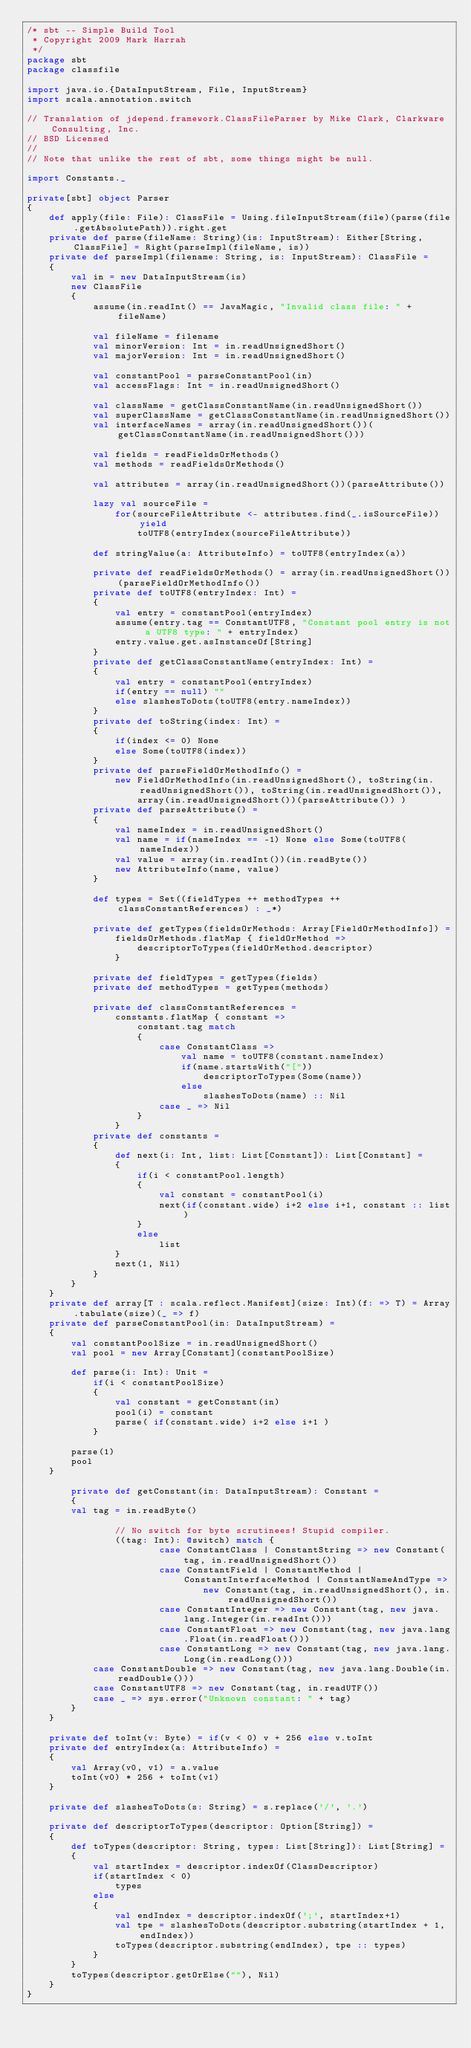<code> <loc_0><loc_0><loc_500><loc_500><_Scala_>/* sbt -- Simple Build Tool
 * Copyright 2009 Mark Harrah
 */
package sbt
package classfile

import java.io.{DataInputStream, File, InputStream}
import scala.annotation.switch

// Translation of jdepend.framework.ClassFileParser by Mike Clark, Clarkware Consulting, Inc.
// BSD Licensed
//
// Note that unlike the rest of sbt, some things might be null.

import Constants._

private[sbt] object Parser
{
	def apply(file: File): ClassFile = Using.fileInputStream(file)(parse(file.getAbsolutePath)).right.get
	private def parse(fileName: String)(is: InputStream): Either[String, ClassFile] = Right(parseImpl(fileName, is))
	private def parseImpl(filename: String, is: InputStream): ClassFile =
	{
		val in = new DataInputStream(is)
		new ClassFile
		{
			assume(in.readInt() == JavaMagic, "Invalid class file: " + fileName)

			val fileName = filename
			val minorVersion: Int = in.readUnsignedShort()
			val majorVersion: Int = in.readUnsignedShort()

			val constantPool = parseConstantPool(in)
			val accessFlags: Int = in.readUnsignedShort()

			val className = getClassConstantName(in.readUnsignedShort())
			val superClassName = getClassConstantName(in.readUnsignedShort())
			val interfaceNames = array(in.readUnsignedShort())(getClassConstantName(in.readUnsignedShort()))

			val fields = readFieldsOrMethods()
			val methods = readFieldsOrMethods()

			val attributes = array(in.readUnsignedShort())(parseAttribute())

			lazy val sourceFile =
				for(sourceFileAttribute <- attributes.find(_.isSourceFile)) yield
					toUTF8(entryIndex(sourceFileAttribute))

			def stringValue(a: AttributeInfo) = toUTF8(entryIndex(a))

			private def readFieldsOrMethods() = array(in.readUnsignedShort())(parseFieldOrMethodInfo())
			private def toUTF8(entryIndex: Int) =
			{
				val entry = constantPool(entryIndex)
				assume(entry.tag == ConstantUTF8, "Constant pool entry is not a UTF8 type: " + entryIndex)
				entry.value.get.asInstanceOf[String]
			}
			private def getClassConstantName(entryIndex: Int) =
			{
				val entry = constantPool(entryIndex)
				if(entry == null) ""
				else slashesToDots(toUTF8(entry.nameIndex))
			}
			private def toString(index: Int) =
			{
				if(index <= 0) None
				else Some(toUTF8(index))
			}
			private def parseFieldOrMethodInfo() =
				new FieldOrMethodInfo(in.readUnsignedShort(), toString(in.readUnsignedShort()), toString(in.readUnsignedShort()),
					array(in.readUnsignedShort())(parseAttribute()) )
			private def parseAttribute() =
			{
				val nameIndex = in.readUnsignedShort()
				val name = if(nameIndex == -1) None else Some(toUTF8(nameIndex))
				val value = array(in.readInt())(in.readByte())
				new AttributeInfo(name, value)
			}

			def types = Set((fieldTypes ++ methodTypes ++ classConstantReferences) : _*)

			private def getTypes(fieldsOrMethods: Array[FieldOrMethodInfo]) =
				fieldsOrMethods.flatMap { fieldOrMethod =>
					descriptorToTypes(fieldOrMethod.descriptor)
				}

			private def fieldTypes = getTypes(fields)
			private def methodTypes = getTypes(methods)

			private def classConstantReferences =
				constants.flatMap { constant =>
					constant.tag match
					{
						case ConstantClass =>
							val name = toUTF8(constant.nameIndex)
							if(name.startsWith("["))
								descriptorToTypes(Some(name))
							else
								slashesToDots(name) :: Nil
						case _ => Nil
					}
				}
			private def constants =
			{
				def next(i: Int, list: List[Constant]): List[Constant] =
				{
					if(i < constantPool.length)
					{
						val constant = constantPool(i)
						next(if(constant.wide) i+2 else i+1, constant :: list)
					}
					else
						list
				}
				next(1, Nil)
			}
		}
    }
    private def array[T : scala.reflect.Manifest](size: Int)(f: => T) = Array.tabulate(size)(_ => f)
	private def parseConstantPool(in: DataInputStream) =
	{
		val constantPoolSize = in.readUnsignedShort()
		val pool = new Array[Constant](constantPoolSize)

		def parse(i: Int): Unit =
			if(i < constantPoolSize)
			{
				val constant = getConstant(in)
				pool(i) = constant
				parse( if(constant.wide) i+2 else i+1 )
			}

		parse(1)
		pool
	}

        private def getConstant(in: DataInputStream): Constant =
        {
		val tag = in.readByte()

                // No switch for byte scrutinees! Stupid compiler.
                ((tag: Int): @switch) match {
                        case ConstantClass | ConstantString => new Constant(tag, in.readUnsignedShort())
                        case ConstantField | ConstantMethod | ConstantInterfaceMethod | ConstantNameAndType =>
                                new Constant(tag, in.readUnsignedShort(), in.readUnsignedShort())
                        case ConstantInteger => new Constant(tag, new java.lang.Integer(in.readInt()))
                        case ConstantFloat => new Constant(tag, new java.lang.Float(in.readFloat()))
                        case ConstantLong => new Constant(tag, new java.lang.Long(in.readLong()))
			case ConstantDouble => new Constant(tag, new java.lang.Double(in.readDouble()))
			case ConstantUTF8 => new Constant(tag, in.readUTF())
			case _ => sys.error("Unknown constant: " + tag)
		}
	}

	private def toInt(v: Byte) = if(v < 0) v + 256 else v.toInt
	private def entryIndex(a: AttributeInfo) =
	{
		val Array(v0, v1) = a.value
		toInt(v0) * 256 + toInt(v1)
	}

	private def slashesToDots(s: String) = s.replace('/', '.')

	private def descriptorToTypes(descriptor: Option[String]) =
	{
		def toTypes(descriptor: String, types: List[String]): List[String] =
		{
			val startIndex = descriptor.indexOf(ClassDescriptor)
			if(startIndex < 0)
				types
			else
			{
				val endIndex = descriptor.indexOf(';', startIndex+1)
				val tpe = slashesToDots(descriptor.substring(startIndex + 1, endIndex))
				toTypes(descriptor.substring(endIndex), tpe :: types)
			}
		}
		toTypes(descriptor.getOrElse(""), Nil)
    }
}
</code> 